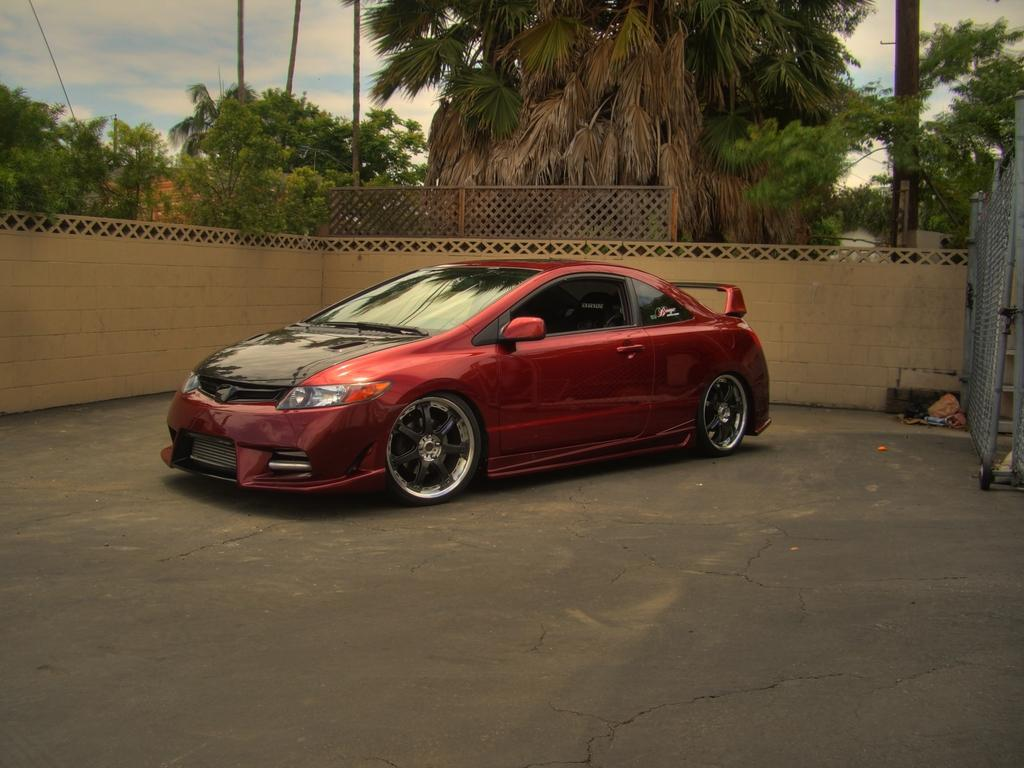What is the main subject in the middle of the image? There is a car in the middle of the image. What can be seen in the background of the image? There are trees and clouds in the background of the image. What is located on the right side of the image? There is a fence on the right side of the image. How much profit does the car generate in the image? The image does not provide any information about the car's profit, as it is a still image and not a representation of a real-life scenario. 